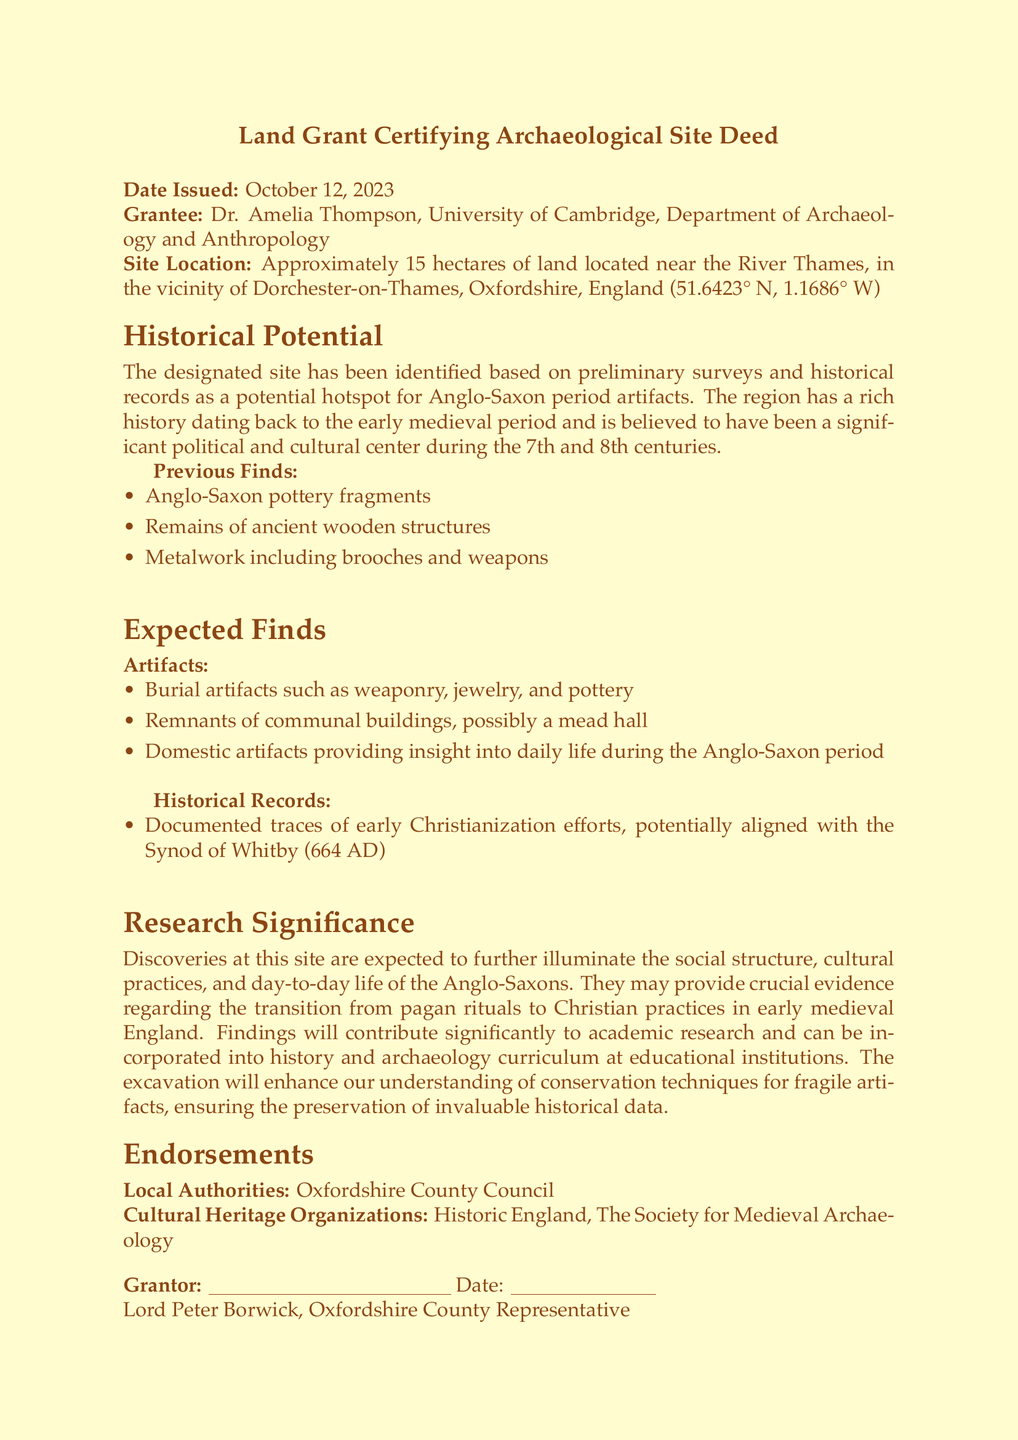What is the date issued? The date issued is mentioned in the document as a specific date the deed was granted.
Answer: October 12, 2023 Who is the grantee? The grantee is noted in the document as the individual or entity receiving the land grant for archaeological research.
Answer: Dr. Amelia Thompson What is the site location? The site location is described in the document with specific geographical coordinates, providing a precise location for excavation.
Answer: Near the River Thames, Dorchester-on-Thames, Oxfordshire, England What are the expected burial artifacts? The document lists examples of artifacts anticipated to be found during the excavation, indicating their relevance to the historical context.
Answer: Weaponry, jewelry, and pottery What is one historical record mentioned? The document includes historical records that correlate with significant events in early medieval England, shedding light on the cultural context.
Answer: Early Christianization efforts How many hectares is the land allocation? The document specifies the size of the land, giving a clear indication of the area designated for archaeological work.
Answer: 15 hectares Who signed as the grantor? The grantor is the official named in the document responsible for the land grant, signifying authority over the land.
Answer: Lord Peter Borwick What archaeological period does the site focus on? The document references a specific historical period, indicating the time frame that the excavation will explore.
Answer: Anglo-Saxon period What is one of the previous finds? The document lists findings from preliminary surveys that supports the site's archaeological significance, indicating a pattern of discovery.
Answer: Anglo-Saxon pottery fragments 